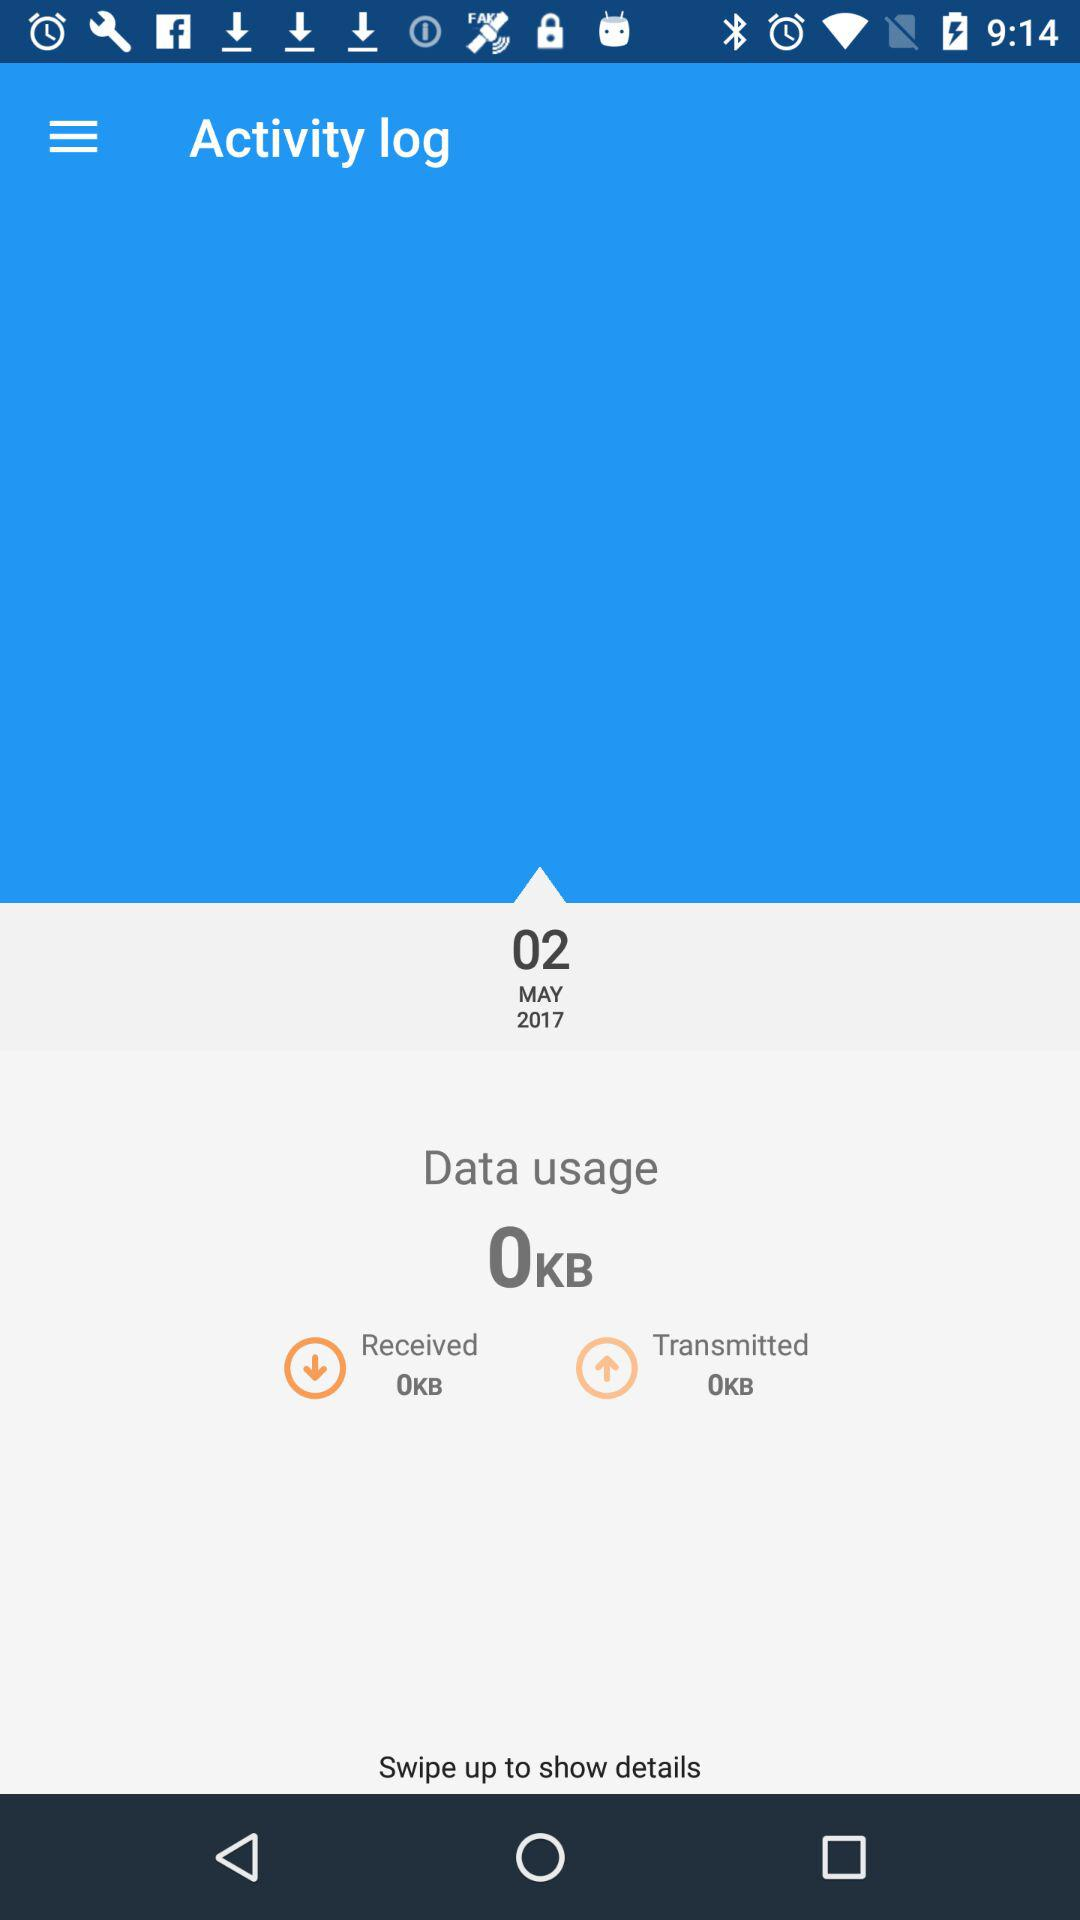How many KB's are received? There are 0 KB received. 